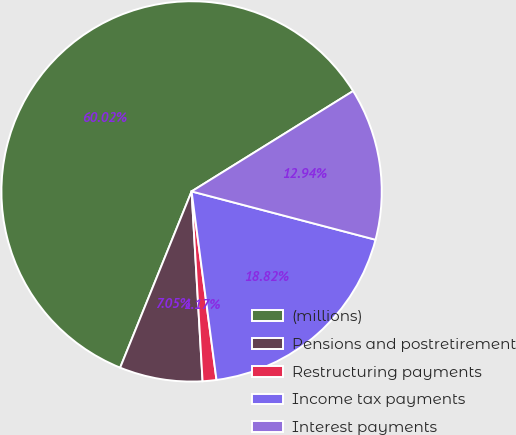<chart> <loc_0><loc_0><loc_500><loc_500><pie_chart><fcel>(millions)<fcel>Pensions and postretirement<fcel>Restructuring payments<fcel>Income tax payments<fcel>Interest payments<nl><fcel>60.02%<fcel>7.05%<fcel>1.17%<fcel>18.82%<fcel>12.94%<nl></chart> 